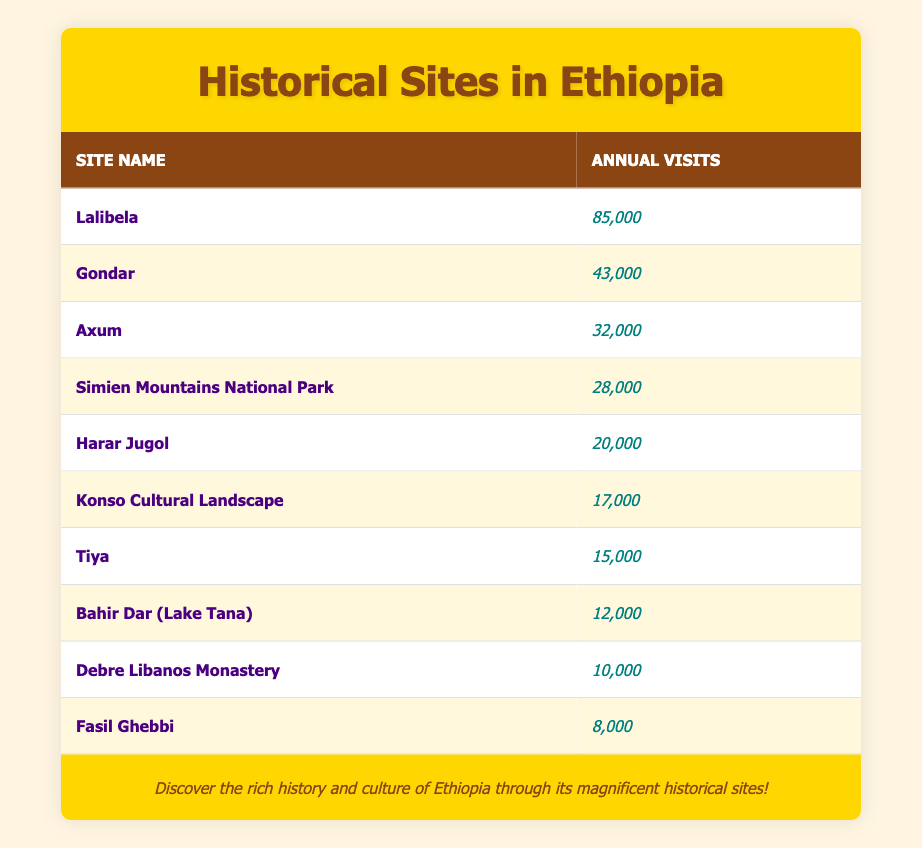What is the site with the highest number of visits? By examining the visits column in the table, Lalibela has the highest number of visits, which is 85,000.
Answer: Lalibela How many visits did Gondar receive? The table lists Gondar with 43,000 visits.
Answer: 43,000 What is the total number of visits for all sites combined? Adding the visits from all sites: 85,000 + 43,000 + 32,000 + 28,000 + 20,000 + 17,000 + 15,000 + 12,000 + 10,000 + 8,000 =  328,000.
Answer: 328,000 Is the number of visits to Axum greater than the number of visits to Harar Jugol? The visits to Axum are 32,000 while Harar Jugol received 20,000 visits. Since 32,000 is greater than 20,000, the statement is true.
Answer: Yes What is the average number of visits for the historical sites listed in the table? To find the average, total visits (328,000) are divided by the number of sites (10): 328,000 / 10 = 32,800.
Answer: 32,800 How many sites had more than 20,000 visits? The sites with more than 20,000 visits are Lalibela, Gondar, Axum, Simien Mountains National Park, and Harar Jugol. This counts up to 5 sites.
Answer: 5 What is the difference in visits between Lalibela and the site with the least visits? Lalibela has 85,000 visits while the least visited site, Fasil Ghebbi, has 8,000 visits. The difference is 85,000 - 8,000 = 77,000.
Answer: 77,000 Do more tourists visit Bahir Dar than Tiya? Bahir Dar has 12,000 visits compared to Tiya which has 15,000 visits. Thus, the answer is false since 12,000 is less than 15,000.
Answer: No Which site has the second highest number of visits? After Lalibela, which has the highest, Gondar follows with 43,000 visits, making it the second highest.
Answer: Gondar 